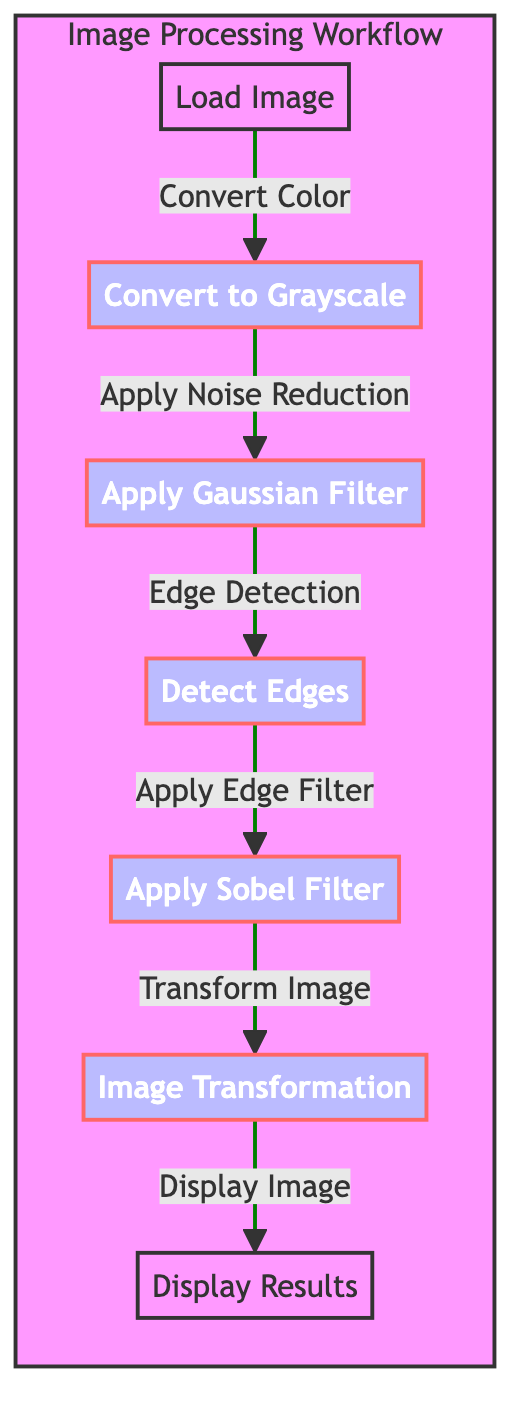What is the first step in the image processing workflow? The first step in the workflow is indicated by the node labeled "Load Image". It is the initial action taken before any other processing steps occur.
Answer: Load Image Which filter is applied after noise reduction? After the "Apply Noise Reduction" step, the next process indicated is "Apply Gaussian Filter". This shows the direct flow from noise reduction to the application of this specific filter.
Answer: Apply Gaussian Filter What is the final step in the workflow? The last operation shown in the workflow is "Display Results", which indicates the output stage after all image processing steps have been completed.
Answer: Display Results How many processing nodes are there in total? The diagram contains a total of six processing nodes, which are indicated by the steps from "Convert to Grayscale" to "Image Transformation".
Answer: Six What is the relationship between edge detection and applying the Sobel filter? The diagram shows that after "Edge Detection," which is "Detect Edges", the next step is "Apply Sobel Filter". Hence, the Sobel filter is directly applied following the edge detection process.
Answer: Apply Sobel Filter Which step comes before image transformation? According to the flowchart, the step that precedes "Image Transformation" is "Apply Sobel Filter". This means the Sobel filter application is a prerequisite to performing the image transformation.
Answer: Apply Sobel Filter What color is used to represent the process nodes in the diagram? The process nodes in the diagram are highlighted in a blue fill color, which visually distinguishes them from the default nodes.
Answer: Blue How does the image processing workflow start? The workflow begins with loading an image, which is the first action taken in the sequence of steps shown in the diagram. This establishes the starting point for processing.
Answer: Load Image What is applied after edge detection? After the edge detection step labeled "Detect Edges," the workflow indicates the application of the "Sobel Filter". This shows a clear ordering of operations in the image processing sequence.
Answer: Apply Sobel Filter 